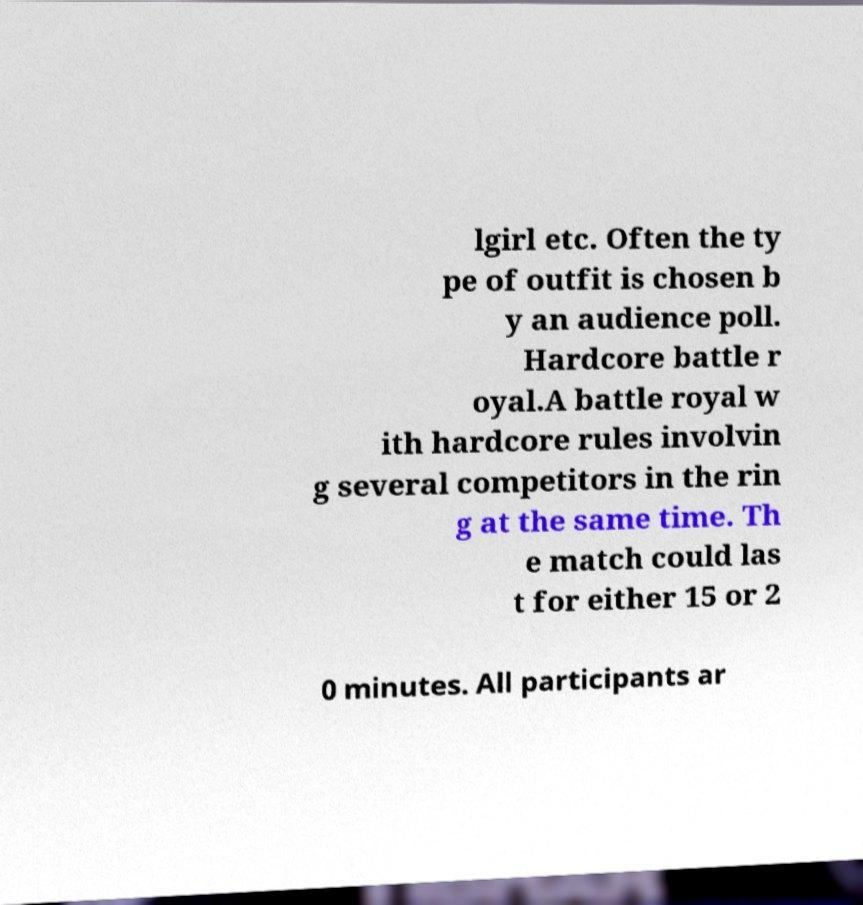Could you assist in decoding the text presented in this image and type it out clearly? lgirl etc. Often the ty pe of outfit is chosen b y an audience poll. Hardcore battle r oyal.A battle royal w ith hardcore rules involvin g several competitors in the rin g at the same time. Th e match could las t for either 15 or 2 0 minutes. All participants ar 